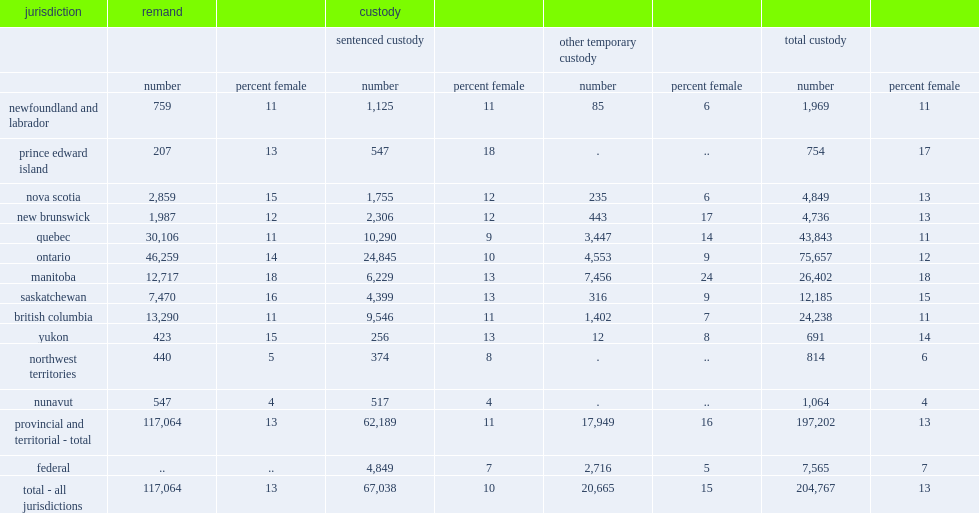According to data from the adult correctional services survey, what was the percentage of females accused being admitted to provincial / territorial custody in canada in 2014/2015? 13.0. According to data from the adult correctional services survey, what was the percentage of females accused being admitted to federal custody in canada in 2014/2015? 7.0. How many jurisdictions exceeded the provincial / territorial average for adult female admissions to provincial / territorial custody in canada in 2014/2015? 0. What was the percentage of adult female admissions to provincial / territorial custody in manitoba in 2014/2015? 18.0. What was the percentage of adult female admissions to provincial / territorial custody in prince edward island in 2014/2015? 17.0. What was the percentage of adult female admissions to provincial / territorial custody in saskatchewan in 2014/2015? 15.0. What was the percentage of adult female admissions to provincial / territorial custody in yukon in 2014/2015? 14.0. 